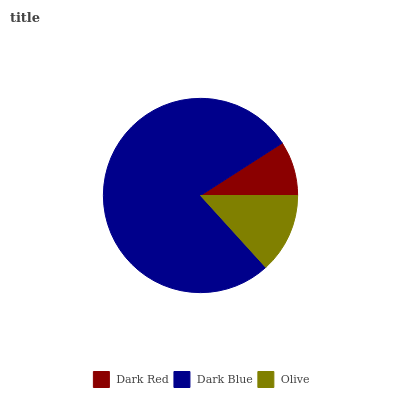Is Dark Red the minimum?
Answer yes or no. Yes. Is Dark Blue the maximum?
Answer yes or no. Yes. Is Olive the minimum?
Answer yes or no. No. Is Olive the maximum?
Answer yes or no. No. Is Dark Blue greater than Olive?
Answer yes or no. Yes. Is Olive less than Dark Blue?
Answer yes or no. Yes. Is Olive greater than Dark Blue?
Answer yes or no. No. Is Dark Blue less than Olive?
Answer yes or no. No. Is Olive the high median?
Answer yes or no. Yes. Is Olive the low median?
Answer yes or no. Yes. Is Dark Red the high median?
Answer yes or no. No. Is Dark Blue the low median?
Answer yes or no. No. 